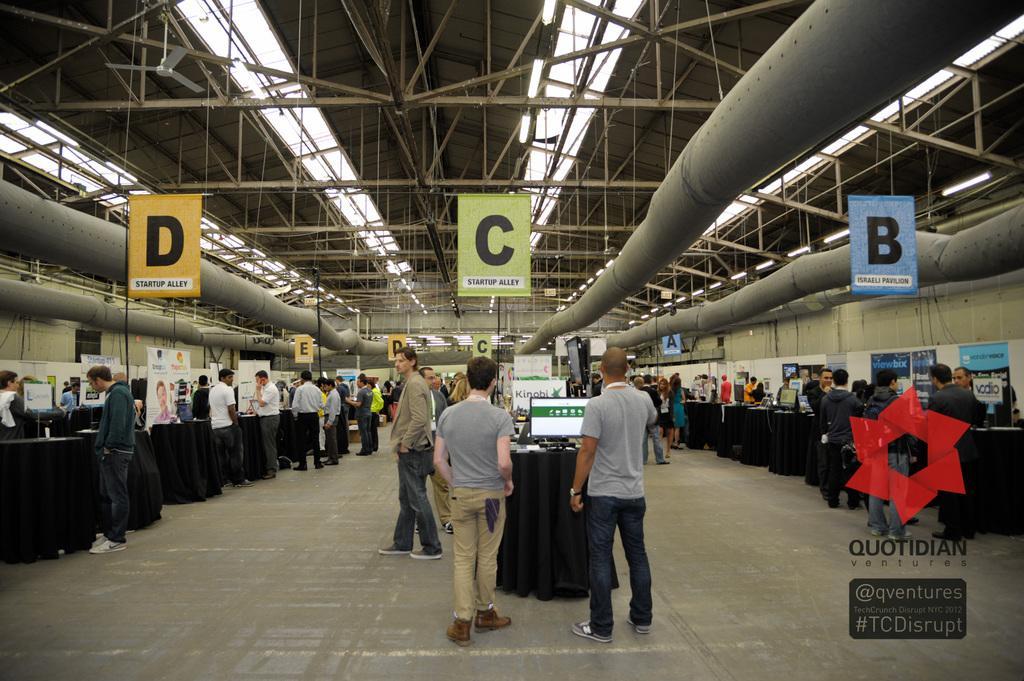Describe this image in one or two sentences. In this image we can see some group of persons standing near the desks on which there are some computers, objects and top of the image there are some vents, pipes, rods, ceiling fans. 